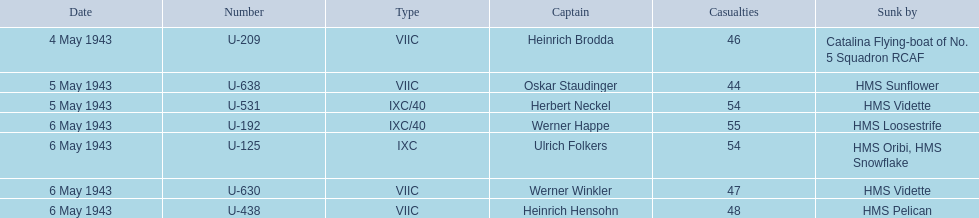Which u-boat initially sank? U-209. 